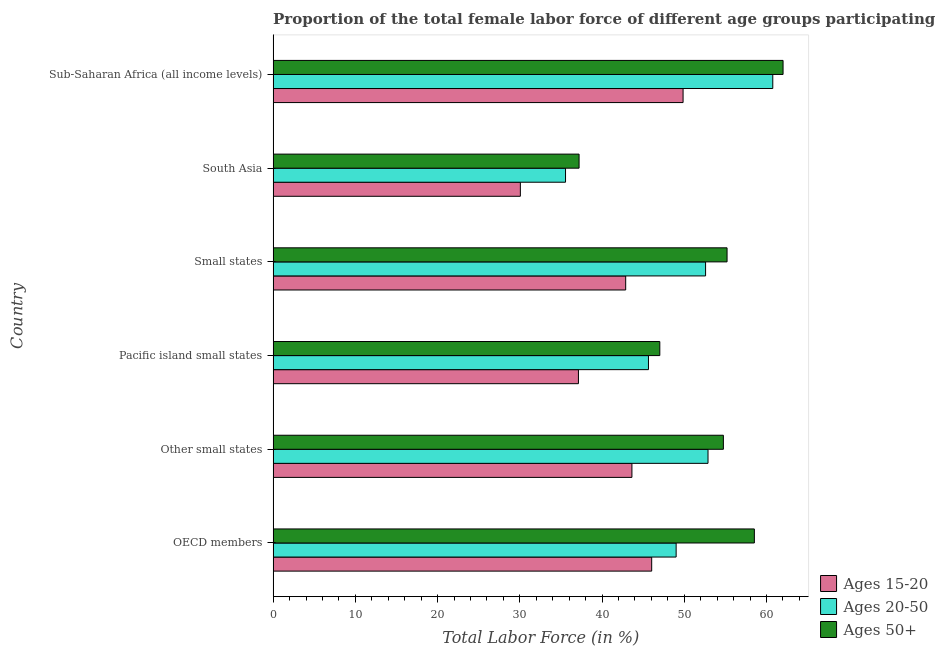Are the number of bars per tick equal to the number of legend labels?
Keep it short and to the point. Yes. In how many cases, is the number of bars for a given country not equal to the number of legend labels?
Your answer should be very brief. 0. What is the percentage of female labor force within the age group 20-50 in OECD members?
Offer a terse response. 49.01. Across all countries, what is the maximum percentage of female labor force within the age group 20-50?
Provide a short and direct response. 60.77. Across all countries, what is the minimum percentage of female labor force within the age group 15-20?
Offer a terse response. 30.07. In which country was the percentage of female labor force above age 50 maximum?
Your answer should be very brief. Sub-Saharan Africa (all income levels). What is the total percentage of female labor force within the age group 20-50 in the graph?
Offer a very short reply. 296.47. What is the difference between the percentage of female labor force within the age group 15-20 in Other small states and that in Pacific island small states?
Keep it short and to the point. 6.5. What is the difference between the percentage of female labor force within the age group 15-20 in Small states and the percentage of female labor force above age 50 in Other small states?
Offer a very short reply. -11.88. What is the average percentage of female labor force within the age group 20-50 per country?
Keep it short and to the point. 49.41. What is the difference between the percentage of female labor force within the age group 15-20 and percentage of female labor force above age 50 in Sub-Saharan Africa (all income levels)?
Your response must be concise. -12.16. What is the ratio of the percentage of female labor force within the age group 20-50 in Pacific island small states to that in Small states?
Your answer should be very brief. 0.87. Is the percentage of female labor force above age 50 in Small states less than that in South Asia?
Keep it short and to the point. No. What is the difference between the highest and the second highest percentage of female labor force within the age group 15-20?
Give a very brief answer. 3.82. What is the difference between the highest and the lowest percentage of female labor force above age 50?
Give a very brief answer. 24.81. What does the 2nd bar from the top in Sub-Saharan Africa (all income levels) represents?
Your response must be concise. Ages 20-50. What does the 1st bar from the bottom in Pacific island small states represents?
Offer a terse response. Ages 15-20. Is it the case that in every country, the sum of the percentage of female labor force within the age group 15-20 and percentage of female labor force within the age group 20-50 is greater than the percentage of female labor force above age 50?
Your response must be concise. Yes. How many bars are there?
Offer a terse response. 18. Are all the bars in the graph horizontal?
Make the answer very short. Yes. How many countries are there in the graph?
Your answer should be compact. 6. Are the values on the major ticks of X-axis written in scientific E-notation?
Offer a very short reply. No. Does the graph contain any zero values?
Keep it short and to the point. No. Does the graph contain grids?
Provide a short and direct response. No. Where does the legend appear in the graph?
Provide a short and direct response. Bottom right. What is the title of the graph?
Keep it short and to the point. Proportion of the total female labor force of different age groups participating in production in 1997. Does "Czech Republic" appear as one of the legend labels in the graph?
Make the answer very short. No. What is the Total Labor Force (in %) in Ages 15-20 in OECD members?
Provide a succinct answer. 46.04. What is the Total Labor Force (in %) in Ages 20-50 in OECD members?
Keep it short and to the point. 49.01. What is the Total Labor Force (in %) of Ages 50+ in OECD members?
Give a very brief answer. 58.53. What is the Total Labor Force (in %) in Ages 15-20 in Other small states?
Your response must be concise. 43.64. What is the Total Labor Force (in %) of Ages 20-50 in Other small states?
Your response must be concise. 52.89. What is the Total Labor Force (in %) in Ages 50+ in Other small states?
Give a very brief answer. 54.76. What is the Total Labor Force (in %) in Ages 15-20 in Pacific island small states?
Make the answer very short. 37.13. What is the Total Labor Force (in %) in Ages 20-50 in Pacific island small states?
Offer a very short reply. 45.65. What is the Total Labor Force (in %) in Ages 50+ in Pacific island small states?
Your answer should be compact. 47.03. What is the Total Labor Force (in %) of Ages 15-20 in Small states?
Offer a terse response. 42.88. What is the Total Labor Force (in %) of Ages 20-50 in Small states?
Provide a short and direct response. 52.59. What is the Total Labor Force (in %) of Ages 50+ in Small states?
Your answer should be compact. 55.21. What is the Total Labor Force (in %) of Ages 15-20 in South Asia?
Provide a succinct answer. 30.07. What is the Total Labor Force (in %) in Ages 20-50 in South Asia?
Provide a succinct answer. 35.56. What is the Total Labor Force (in %) of Ages 50+ in South Asia?
Provide a short and direct response. 37.21. What is the Total Labor Force (in %) in Ages 15-20 in Sub-Saharan Africa (all income levels)?
Your answer should be very brief. 49.86. What is the Total Labor Force (in %) in Ages 20-50 in Sub-Saharan Africa (all income levels)?
Keep it short and to the point. 60.77. What is the Total Labor Force (in %) of Ages 50+ in Sub-Saharan Africa (all income levels)?
Give a very brief answer. 62.02. Across all countries, what is the maximum Total Labor Force (in %) in Ages 15-20?
Your answer should be very brief. 49.86. Across all countries, what is the maximum Total Labor Force (in %) of Ages 20-50?
Offer a terse response. 60.77. Across all countries, what is the maximum Total Labor Force (in %) of Ages 50+?
Your response must be concise. 62.02. Across all countries, what is the minimum Total Labor Force (in %) in Ages 15-20?
Offer a terse response. 30.07. Across all countries, what is the minimum Total Labor Force (in %) of Ages 20-50?
Give a very brief answer. 35.56. Across all countries, what is the minimum Total Labor Force (in %) of Ages 50+?
Provide a short and direct response. 37.21. What is the total Total Labor Force (in %) of Ages 15-20 in the graph?
Ensure brevity in your answer.  249.61. What is the total Total Labor Force (in %) of Ages 20-50 in the graph?
Your answer should be very brief. 296.47. What is the total Total Labor Force (in %) of Ages 50+ in the graph?
Give a very brief answer. 314.74. What is the difference between the Total Labor Force (in %) of Ages 15-20 in OECD members and that in Other small states?
Make the answer very short. 2.4. What is the difference between the Total Labor Force (in %) in Ages 20-50 in OECD members and that in Other small states?
Keep it short and to the point. -3.88. What is the difference between the Total Labor Force (in %) in Ages 50+ in OECD members and that in Other small states?
Your answer should be compact. 3.77. What is the difference between the Total Labor Force (in %) in Ages 15-20 in OECD members and that in Pacific island small states?
Make the answer very short. 8.91. What is the difference between the Total Labor Force (in %) of Ages 20-50 in OECD members and that in Pacific island small states?
Keep it short and to the point. 3.37. What is the difference between the Total Labor Force (in %) of Ages 50+ in OECD members and that in Pacific island small states?
Ensure brevity in your answer.  11.5. What is the difference between the Total Labor Force (in %) of Ages 15-20 in OECD members and that in Small states?
Your response must be concise. 3.16. What is the difference between the Total Labor Force (in %) of Ages 20-50 in OECD members and that in Small states?
Your answer should be compact. -3.58. What is the difference between the Total Labor Force (in %) in Ages 50+ in OECD members and that in Small states?
Offer a very short reply. 3.32. What is the difference between the Total Labor Force (in %) in Ages 15-20 in OECD members and that in South Asia?
Offer a terse response. 15.97. What is the difference between the Total Labor Force (in %) of Ages 20-50 in OECD members and that in South Asia?
Your response must be concise. 13.45. What is the difference between the Total Labor Force (in %) of Ages 50+ in OECD members and that in South Asia?
Give a very brief answer. 21.32. What is the difference between the Total Labor Force (in %) of Ages 15-20 in OECD members and that in Sub-Saharan Africa (all income levels)?
Give a very brief answer. -3.82. What is the difference between the Total Labor Force (in %) in Ages 20-50 in OECD members and that in Sub-Saharan Africa (all income levels)?
Make the answer very short. -11.75. What is the difference between the Total Labor Force (in %) of Ages 50+ in OECD members and that in Sub-Saharan Africa (all income levels)?
Keep it short and to the point. -3.49. What is the difference between the Total Labor Force (in %) in Ages 15-20 in Other small states and that in Pacific island small states?
Provide a succinct answer. 6.51. What is the difference between the Total Labor Force (in %) in Ages 20-50 in Other small states and that in Pacific island small states?
Give a very brief answer. 7.24. What is the difference between the Total Labor Force (in %) in Ages 50+ in Other small states and that in Pacific island small states?
Give a very brief answer. 7.73. What is the difference between the Total Labor Force (in %) of Ages 15-20 in Other small states and that in Small states?
Make the answer very short. 0.76. What is the difference between the Total Labor Force (in %) in Ages 20-50 in Other small states and that in Small states?
Provide a short and direct response. 0.3. What is the difference between the Total Labor Force (in %) in Ages 50+ in Other small states and that in Small states?
Make the answer very short. -0.45. What is the difference between the Total Labor Force (in %) of Ages 15-20 in Other small states and that in South Asia?
Your answer should be very brief. 13.57. What is the difference between the Total Labor Force (in %) of Ages 20-50 in Other small states and that in South Asia?
Provide a short and direct response. 17.33. What is the difference between the Total Labor Force (in %) in Ages 50+ in Other small states and that in South Asia?
Offer a terse response. 17.55. What is the difference between the Total Labor Force (in %) of Ages 15-20 in Other small states and that in Sub-Saharan Africa (all income levels)?
Your answer should be very brief. -6.22. What is the difference between the Total Labor Force (in %) in Ages 20-50 in Other small states and that in Sub-Saharan Africa (all income levels)?
Offer a very short reply. -7.88. What is the difference between the Total Labor Force (in %) of Ages 50+ in Other small states and that in Sub-Saharan Africa (all income levels)?
Offer a terse response. -7.26. What is the difference between the Total Labor Force (in %) in Ages 15-20 in Pacific island small states and that in Small states?
Your response must be concise. -5.75. What is the difference between the Total Labor Force (in %) in Ages 20-50 in Pacific island small states and that in Small states?
Provide a short and direct response. -6.95. What is the difference between the Total Labor Force (in %) of Ages 50+ in Pacific island small states and that in Small states?
Provide a short and direct response. -8.18. What is the difference between the Total Labor Force (in %) of Ages 15-20 in Pacific island small states and that in South Asia?
Offer a terse response. 7.06. What is the difference between the Total Labor Force (in %) of Ages 20-50 in Pacific island small states and that in South Asia?
Offer a very short reply. 10.09. What is the difference between the Total Labor Force (in %) in Ages 50+ in Pacific island small states and that in South Asia?
Provide a succinct answer. 9.82. What is the difference between the Total Labor Force (in %) in Ages 15-20 in Pacific island small states and that in Sub-Saharan Africa (all income levels)?
Provide a succinct answer. -12.72. What is the difference between the Total Labor Force (in %) of Ages 20-50 in Pacific island small states and that in Sub-Saharan Africa (all income levels)?
Your response must be concise. -15.12. What is the difference between the Total Labor Force (in %) in Ages 50+ in Pacific island small states and that in Sub-Saharan Africa (all income levels)?
Give a very brief answer. -14.99. What is the difference between the Total Labor Force (in %) in Ages 15-20 in Small states and that in South Asia?
Offer a terse response. 12.81. What is the difference between the Total Labor Force (in %) of Ages 20-50 in Small states and that in South Asia?
Provide a succinct answer. 17.03. What is the difference between the Total Labor Force (in %) in Ages 50+ in Small states and that in South Asia?
Your answer should be very brief. 18. What is the difference between the Total Labor Force (in %) of Ages 15-20 in Small states and that in Sub-Saharan Africa (all income levels)?
Offer a very short reply. -6.98. What is the difference between the Total Labor Force (in %) in Ages 20-50 in Small states and that in Sub-Saharan Africa (all income levels)?
Provide a short and direct response. -8.17. What is the difference between the Total Labor Force (in %) of Ages 50+ in Small states and that in Sub-Saharan Africa (all income levels)?
Make the answer very short. -6.81. What is the difference between the Total Labor Force (in %) in Ages 15-20 in South Asia and that in Sub-Saharan Africa (all income levels)?
Ensure brevity in your answer.  -19.79. What is the difference between the Total Labor Force (in %) of Ages 20-50 in South Asia and that in Sub-Saharan Africa (all income levels)?
Ensure brevity in your answer.  -25.21. What is the difference between the Total Labor Force (in %) of Ages 50+ in South Asia and that in Sub-Saharan Africa (all income levels)?
Provide a short and direct response. -24.81. What is the difference between the Total Labor Force (in %) in Ages 15-20 in OECD members and the Total Labor Force (in %) in Ages 20-50 in Other small states?
Provide a short and direct response. -6.85. What is the difference between the Total Labor Force (in %) of Ages 15-20 in OECD members and the Total Labor Force (in %) of Ages 50+ in Other small states?
Ensure brevity in your answer.  -8.72. What is the difference between the Total Labor Force (in %) of Ages 20-50 in OECD members and the Total Labor Force (in %) of Ages 50+ in Other small states?
Give a very brief answer. -5.74. What is the difference between the Total Labor Force (in %) in Ages 15-20 in OECD members and the Total Labor Force (in %) in Ages 20-50 in Pacific island small states?
Ensure brevity in your answer.  0.39. What is the difference between the Total Labor Force (in %) of Ages 15-20 in OECD members and the Total Labor Force (in %) of Ages 50+ in Pacific island small states?
Your answer should be compact. -0.99. What is the difference between the Total Labor Force (in %) in Ages 20-50 in OECD members and the Total Labor Force (in %) in Ages 50+ in Pacific island small states?
Your response must be concise. 1.98. What is the difference between the Total Labor Force (in %) of Ages 15-20 in OECD members and the Total Labor Force (in %) of Ages 20-50 in Small states?
Offer a terse response. -6.55. What is the difference between the Total Labor Force (in %) of Ages 15-20 in OECD members and the Total Labor Force (in %) of Ages 50+ in Small states?
Offer a very short reply. -9.16. What is the difference between the Total Labor Force (in %) in Ages 20-50 in OECD members and the Total Labor Force (in %) in Ages 50+ in Small states?
Ensure brevity in your answer.  -6.19. What is the difference between the Total Labor Force (in %) of Ages 15-20 in OECD members and the Total Labor Force (in %) of Ages 20-50 in South Asia?
Your response must be concise. 10.48. What is the difference between the Total Labor Force (in %) in Ages 15-20 in OECD members and the Total Labor Force (in %) in Ages 50+ in South Asia?
Make the answer very short. 8.83. What is the difference between the Total Labor Force (in %) of Ages 20-50 in OECD members and the Total Labor Force (in %) of Ages 50+ in South Asia?
Provide a succinct answer. 11.8. What is the difference between the Total Labor Force (in %) in Ages 15-20 in OECD members and the Total Labor Force (in %) in Ages 20-50 in Sub-Saharan Africa (all income levels)?
Offer a very short reply. -14.73. What is the difference between the Total Labor Force (in %) of Ages 15-20 in OECD members and the Total Labor Force (in %) of Ages 50+ in Sub-Saharan Africa (all income levels)?
Offer a very short reply. -15.98. What is the difference between the Total Labor Force (in %) of Ages 20-50 in OECD members and the Total Labor Force (in %) of Ages 50+ in Sub-Saharan Africa (all income levels)?
Offer a terse response. -13. What is the difference between the Total Labor Force (in %) of Ages 15-20 in Other small states and the Total Labor Force (in %) of Ages 20-50 in Pacific island small states?
Your response must be concise. -2.01. What is the difference between the Total Labor Force (in %) in Ages 15-20 in Other small states and the Total Labor Force (in %) in Ages 50+ in Pacific island small states?
Offer a very short reply. -3.39. What is the difference between the Total Labor Force (in %) of Ages 20-50 in Other small states and the Total Labor Force (in %) of Ages 50+ in Pacific island small states?
Give a very brief answer. 5.86. What is the difference between the Total Labor Force (in %) in Ages 15-20 in Other small states and the Total Labor Force (in %) in Ages 20-50 in Small states?
Your answer should be very brief. -8.96. What is the difference between the Total Labor Force (in %) of Ages 15-20 in Other small states and the Total Labor Force (in %) of Ages 50+ in Small states?
Your answer should be very brief. -11.57. What is the difference between the Total Labor Force (in %) of Ages 20-50 in Other small states and the Total Labor Force (in %) of Ages 50+ in Small states?
Give a very brief answer. -2.32. What is the difference between the Total Labor Force (in %) of Ages 15-20 in Other small states and the Total Labor Force (in %) of Ages 20-50 in South Asia?
Make the answer very short. 8.07. What is the difference between the Total Labor Force (in %) of Ages 15-20 in Other small states and the Total Labor Force (in %) of Ages 50+ in South Asia?
Offer a very short reply. 6.43. What is the difference between the Total Labor Force (in %) in Ages 20-50 in Other small states and the Total Labor Force (in %) in Ages 50+ in South Asia?
Offer a very short reply. 15.68. What is the difference between the Total Labor Force (in %) of Ages 15-20 in Other small states and the Total Labor Force (in %) of Ages 20-50 in Sub-Saharan Africa (all income levels)?
Your response must be concise. -17.13. What is the difference between the Total Labor Force (in %) of Ages 15-20 in Other small states and the Total Labor Force (in %) of Ages 50+ in Sub-Saharan Africa (all income levels)?
Your answer should be compact. -18.38. What is the difference between the Total Labor Force (in %) of Ages 20-50 in Other small states and the Total Labor Force (in %) of Ages 50+ in Sub-Saharan Africa (all income levels)?
Make the answer very short. -9.13. What is the difference between the Total Labor Force (in %) of Ages 15-20 in Pacific island small states and the Total Labor Force (in %) of Ages 20-50 in Small states?
Keep it short and to the point. -15.46. What is the difference between the Total Labor Force (in %) in Ages 15-20 in Pacific island small states and the Total Labor Force (in %) in Ages 50+ in Small states?
Your answer should be very brief. -18.07. What is the difference between the Total Labor Force (in %) of Ages 20-50 in Pacific island small states and the Total Labor Force (in %) of Ages 50+ in Small states?
Provide a short and direct response. -9.56. What is the difference between the Total Labor Force (in %) in Ages 15-20 in Pacific island small states and the Total Labor Force (in %) in Ages 20-50 in South Asia?
Provide a short and direct response. 1.57. What is the difference between the Total Labor Force (in %) of Ages 15-20 in Pacific island small states and the Total Labor Force (in %) of Ages 50+ in South Asia?
Provide a succinct answer. -0.08. What is the difference between the Total Labor Force (in %) in Ages 20-50 in Pacific island small states and the Total Labor Force (in %) in Ages 50+ in South Asia?
Your answer should be compact. 8.44. What is the difference between the Total Labor Force (in %) in Ages 15-20 in Pacific island small states and the Total Labor Force (in %) in Ages 20-50 in Sub-Saharan Africa (all income levels)?
Ensure brevity in your answer.  -23.64. What is the difference between the Total Labor Force (in %) of Ages 15-20 in Pacific island small states and the Total Labor Force (in %) of Ages 50+ in Sub-Saharan Africa (all income levels)?
Give a very brief answer. -24.88. What is the difference between the Total Labor Force (in %) of Ages 20-50 in Pacific island small states and the Total Labor Force (in %) of Ages 50+ in Sub-Saharan Africa (all income levels)?
Give a very brief answer. -16.37. What is the difference between the Total Labor Force (in %) in Ages 15-20 in Small states and the Total Labor Force (in %) in Ages 20-50 in South Asia?
Keep it short and to the point. 7.32. What is the difference between the Total Labor Force (in %) of Ages 15-20 in Small states and the Total Labor Force (in %) of Ages 50+ in South Asia?
Your answer should be compact. 5.67. What is the difference between the Total Labor Force (in %) in Ages 20-50 in Small states and the Total Labor Force (in %) in Ages 50+ in South Asia?
Your answer should be compact. 15.39. What is the difference between the Total Labor Force (in %) in Ages 15-20 in Small states and the Total Labor Force (in %) in Ages 20-50 in Sub-Saharan Africa (all income levels)?
Provide a short and direct response. -17.89. What is the difference between the Total Labor Force (in %) in Ages 15-20 in Small states and the Total Labor Force (in %) in Ages 50+ in Sub-Saharan Africa (all income levels)?
Provide a short and direct response. -19.14. What is the difference between the Total Labor Force (in %) in Ages 20-50 in Small states and the Total Labor Force (in %) in Ages 50+ in Sub-Saharan Africa (all income levels)?
Keep it short and to the point. -9.42. What is the difference between the Total Labor Force (in %) of Ages 15-20 in South Asia and the Total Labor Force (in %) of Ages 20-50 in Sub-Saharan Africa (all income levels)?
Offer a very short reply. -30.7. What is the difference between the Total Labor Force (in %) of Ages 15-20 in South Asia and the Total Labor Force (in %) of Ages 50+ in Sub-Saharan Africa (all income levels)?
Your answer should be very brief. -31.95. What is the difference between the Total Labor Force (in %) in Ages 20-50 in South Asia and the Total Labor Force (in %) in Ages 50+ in Sub-Saharan Africa (all income levels)?
Ensure brevity in your answer.  -26.45. What is the average Total Labor Force (in %) of Ages 15-20 per country?
Your answer should be compact. 41.6. What is the average Total Labor Force (in %) in Ages 20-50 per country?
Your answer should be compact. 49.41. What is the average Total Labor Force (in %) of Ages 50+ per country?
Offer a very short reply. 52.46. What is the difference between the Total Labor Force (in %) of Ages 15-20 and Total Labor Force (in %) of Ages 20-50 in OECD members?
Give a very brief answer. -2.97. What is the difference between the Total Labor Force (in %) in Ages 15-20 and Total Labor Force (in %) in Ages 50+ in OECD members?
Keep it short and to the point. -12.49. What is the difference between the Total Labor Force (in %) of Ages 20-50 and Total Labor Force (in %) of Ages 50+ in OECD members?
Provide a short and direct response. -9.51. What is the difference between the Total Labor Force (in %) in Ages 15-20 and Total Labor Force (in %) in Ages 20-50 in Other small states?
Provide a succinct answer. -9.25. What is the difference between the Total Labor Force (in %) of Ages 15-20 and Total Labor Force (in %) of Ages 50+ in Other small states?
Make the answer very short. -11.12. What is the difference between the Total Labor Force (in %) in Ages 20-50 and Total Labor Force (in %) in Ages 50+ in Other small states?
Offer a terse response. -1.87. What is the difference between the Total Labor Force (in %) in Ages 15-20 and Total Labor Force (in %) in Ages 20-50 in Pacific island small states?
Your answer should be very brief. -8.52. What is the difference between the Total Labor Force (in %) in Ages 15-20 and Total Labor Force (in %) in Ages 50+ in Pacific island small states?
Give a very brief answer. -9.9. What is the difference between the Total Labor Force (in %) in Ages 20-50 and Total Labor Force (in %) in Ages 50+ in Pacific island small states?
Offer a terse response. -1.38. What is the difference between the Total Labor Force (in %) of Ages 15-20 and Total Labor Force (in %) of Ages 20-50 in Small states?
Keep it short and to the point. -9.72. What is the difference between the Total Labor Force (in %) of Ages 15-20 and Total Labor Force (in %) of Ages 50+ in Small states?
Your answer should be very brief. -12.33. What is the difference between the Total Labor Force (in %) in Ages 20-50 and Total Labor Force (in %) in Ages 50+ in Small states?
Your answer should be very brief. -2.61. What is the difference between the Total Labor Force (in %) of Ages 15-20 and Total Labor Force (in %) of Ages 20-50 in South Asia?
Offer a very short reply. -5.49. What is the difference between the Total Labor Force (in %) of Ages 15-20 and Total Labor Force (in %) of Ages 50+ in South Asia?
Offer a terse response. -7.14. What is the difference between the Total Labor Force (in %) of Ages 20-50 and Total Labor Force (in %) of Ages 50+ in South Asia?
Offer a terse response. -1.65. What is the difference between the Total Labor Force (in %) of Ages 15-20 and Total Labor Force (in %) of Ages 20-50 in Sub-Saharan Africa (all income levels)?
Your answer should be very brief. -10.91. What is the difference between the Total Labor Force (in %) in Ages 15-20 and Total Labor Force (in %) in Ages 50+ in Sub-Saharan Africa (all income levels)?
Give a very brief answer. -12.16. What is the difference between the Total Labor Force (in %) of Ages 20-50 and Total Labor Force (in %) of Ages 50+ in Sub-Saharan Africa (all income levels)?
Offer a terse response. -1.25. What is the ratio of the Total Labor Force (in %) of Ages 15-20 in OECD members to that in Other small states?
Offer a very short reply. 1.06. What is the ratio of the Total Labor Force (in %) in Ages 20-50 in OECD members to that in Other small states?
Provide a succinct answer. 0.93. What is the ratio of the Total Labor Force (in %) of Ages 50+ in OECD members to that in Other small states?
Your answer should be compact. 1.07. What is the ratio of the Total Labor Force (in %) of Ages 15-20 in OECD members to that in Pacific island small states?
Your response must be concise. 1.24. What is the ratio of the Total Labor Force (in %) in Ages 20-50 in OECD members to that in Pacific island small states?
Ensure brevity in your answer.  1.07. What is the ratio of the Total Labor Force (in %) of Ages 50+ in OECD members to that in Pacific island small states?
Keep it short and to the point. 1.24. What is the ratio of the Total Labor Force (in %) in Ages 15-20 in OECD members to that in Small states?
Make the answer very short. 1.07. What is the ratio of the Total Labor Force (in %) of Ages 20-50 in OECD members to that in Small states?
Offer a very short reply. 0.93. What is the ratio of the Total Labor Force (in %) in Ages 50+ in OECD members to that in Small states?
Offer a terse response. 1.06. What is the ratio of the Total Labor Force (in %) of Ages 15-20 in OECD members to that in South Asia?
Your response must be concise. 1.53. What is the ratio of the Total Labor Force (in %) in Ages 20-50 in OECD members to that in South Asia?
Your response must be concise. 1.38. What is the ratio of the Total Labor Force (in %) in Ages 50+ in OECD members to that in South Asia?
Provide a short and direct response. 1.57. What is the ratio of the Total Labor Force (in %) of Ages 15-20 in OECD members to that in Sub-Saharan Africa (all income levels)?
Your answer should be very brief. 0.92. What is the ratio of the Total Labor Force (in %) in Ages 20-50 in OECD members to that in Sub-Saharan Africa (all income levels)?
Make the answer very short. 0.81. What is the ratio of the Total Labor Force (in %) of Ages 50+ in OECD members to that in Sub-Saharan Africa (all income levels)?
Provide a short and direct response. 0.94. What is the ratio of the Total Labor Force (in %) in Ages 15-20 in Other small states to that in Pacific island small states?
Offer a terse response. 1.18. What is the ratio of the Total Labor Force (in %) in Ages 20-50 in Other small states to that in Pacific island small states?
Offer a terse response. 1.16. What is the ratio of the Total Labor Force (in %) in Ages 50+ in Other small states to that in Pacific island small states?
Offer a very short reply. 1.16. What is the ratio of the Total Labor Force (in %) of Ages 15-20 in Other small states to that in Small states?
Offer a terse response. 1.02. What is the ratio of the Total Labor Force (in %) in Ages 20-50 in Other small states to that in Small states?
Your answer should be very brief. 1.01. What is the ratio of the Total Labor Force (in %) in Ages 50+ in Other small states to that in Small states?
Offer a terse response. 0.99. What is the ratio of the Total Labor Force (in %) in Ages 15-20 in Other small states to that in South Asia?
Provide a succinct answer. 1.45. What is the ratio of the Total Labor Force (in %) of Ages 20-50 in Other small states to that in South Asia?
Your response must be concise. 1.49. What is the ratio of the Total Labor Force (in %) of Ages 50+ in Other small states to that in South Asia?
Your answer should be compact. 1.47. What is the ratio of the Total Labor Force (in %) of Ages 15-20 in Other small states to that in Sub-Saharan Africa (all income levels)?
Your response must be concise. 0.88. What is the ratio of the Total Labor Force (in %) of Ages 20-50 in Other small states to that in Sub-Saharan Africa (all income levels)?
Keep it short and to the point. 0.87. What is the ratio of the Total Labor Force (in %) in Ages 50+ in Other small states to that in Sub-Saharan Africa (all income levels)?
Give a very brief answer. 0.88. What is the ratio of the Total Labor Force (in %) of Ages 15-20 in Pacific island small states to that in Small states?
Ensure brevity in your answer.  0.87. What is the ratio of the Total Labor Force (in %) of Ages 20-50 in Pacific island small states to that in Small states?
Your answer should be compact. 0.87. What is the ratio of the Total Labor Force (in %) of Ages 50+ in Pacific island small states to that in Small states?
Ensure brevity in your answer.  0.85. What is the ratio of the Total Labor Force (in %) of Ages 15-20 in Pacific island small states to that in South Asia?
Keep it short and to the point. 1.23. What is the ratio of the Total Labor Force (in %) in Ages 20-50 in Pacific island small states to that in South Asia?
Provide a succinct answer. 1.28. What is the ratio of the Total Labor Force (in %) in Ages 50+ in Pacific island small states to that in South Asia?
Your response must be concise. 1.26. What is the ratio of the Total Labor Force (in %) in Ages 15-20 in Pacific island small states to that in Sub-Saharan Africa (all income levels)?
Your answer should be very brief. 0.74. What is the ratio of the Total Labor Force (in %) in Ages 20-50 in Pacific island small states to that in Sub-Saharan Africa (all income levels)?
Your response must be concise. 0.75. What is the ratio of the Total Labor Force (in %) in Ages 50+ in Pacific island small states to that in Sub-Saharan Africa (all income levels)?
Provide a short and direct response. 0.76. What is the ratio of the Total Labor Force (in %) in Ages 15-20 in Small states to that in South Asia?
Your answer should be compact. 1.43. What is the ratio of the Total Labor Force (in %) of Ages 20-50 in Small states to that in South Asia?
Keep it short and to the point. 1.48. What is the ratio of the Total Labor Force (in %) of Ages 50+ in Small states to that in South Asia?
Give a very brief answer. 1.48. What is the ratio of the Total Labor Force (in %) in Ages 15-20 in Small states to that in Sub-Saharan Africa (all income levels)?
Your response must be concise. 0.86. What is the ratio of the Total Labor Force (in %) of Ages 20-50 in Small states to that in Sub-Saharan Africa (all income levels)?
Provide a short and direct response. 0.87. What is the ratio of the Total Labor Force (in %) in Ages 50+ in Small states to that in Sub-Saharan Africa (all income levels)?
Ensure brevity in your answer.  0.89. What is the ratio of the Total Labor Force (in %) in Ages 15-20 in South Asia to that in Sub-Saharan Africa (all income levels)?
Provide a short and direct response. 0.6. What is the ratio of the Total Labor Force (in %) of Ages 20-50 in South Asia to that in Sub-Saharan Africa (all income levels)?
Ensure brevity in your answer.  0.59. What is the difference between the highest and the second highest Total Labor Force (in %) of Ages 15-20?
Make the answer very short. 3.82. What is the difference between the highest and the second highest Total Labor Force (in %) in Ages 20-50?
Ensure brevity in your answer.  7.88. What is the difference between the highest and the second highest Total Labor Force (in %) of Ages 50+?
Give a very brief answer. 3.49. What is the difference between the highest and the lowest Total Labor Force (in %) of Ages 15-20?
Provide a succinct answer. 19.79. What is the difference between the highest and the lowest Total Labor Force (in %) of Ages 20-50?
Keep it short and to the point. 25.21. What is the difference between the highest and the lowest Total Labor Force (in %) in Ages 50+?
Offer a terse response. 24.81. 